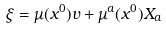<formula> <loc_0><loc_0><loc_500><loc_500>\xi = \mu ( x ^ { 0 } ) v + \mu ^ { a } ( x ^ { 0 } ) X _ { a }</formula> 